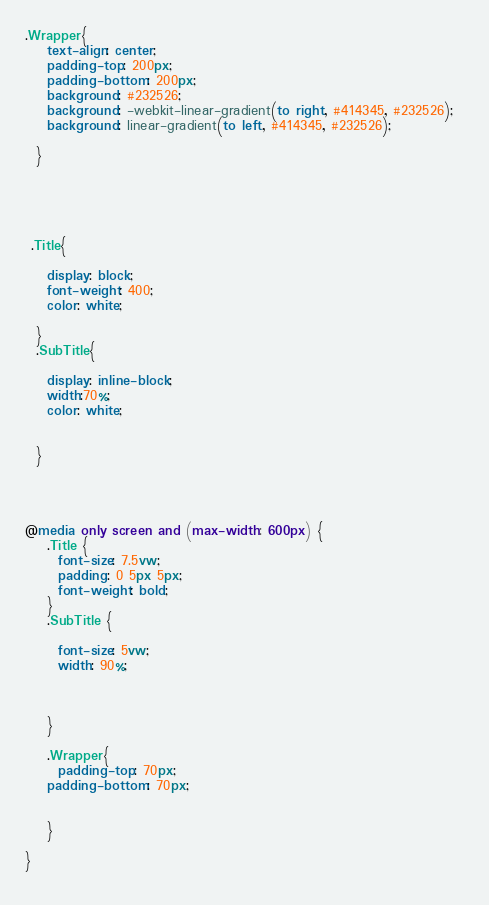<code> <loc_0><loc_0><loc_500><loc_500><_CSS_>.Wrapper{ 
    text-align: center;
    padding-top: 200px;
    padding-bottom: 200px;
    background: #232526;  
    background: -webkit-linear-gradient(to right, #414345, #232526);  
    background: linear-gradient(to left, #414345, #232526); 

  }




  
 .Title{

    display: block;
    font-weight: 400;
    color: white;

  }
  .SubTitle{

    display: inline-block;
    width:70%;
    color: white;

    
  }




@media only screen and (max-width: 600px) {
    .Title {
      font-size: 7.5vw;
      padding: 0 5px 5px;
      font-weight: bold;
    }
    .SubTitle {
      
      font-size: 5vw;
      width: 90%;



    }

    .Wrapper{
      padding-top: 70px;
    padding-bottom: 70px;


    }

}
  </code> 